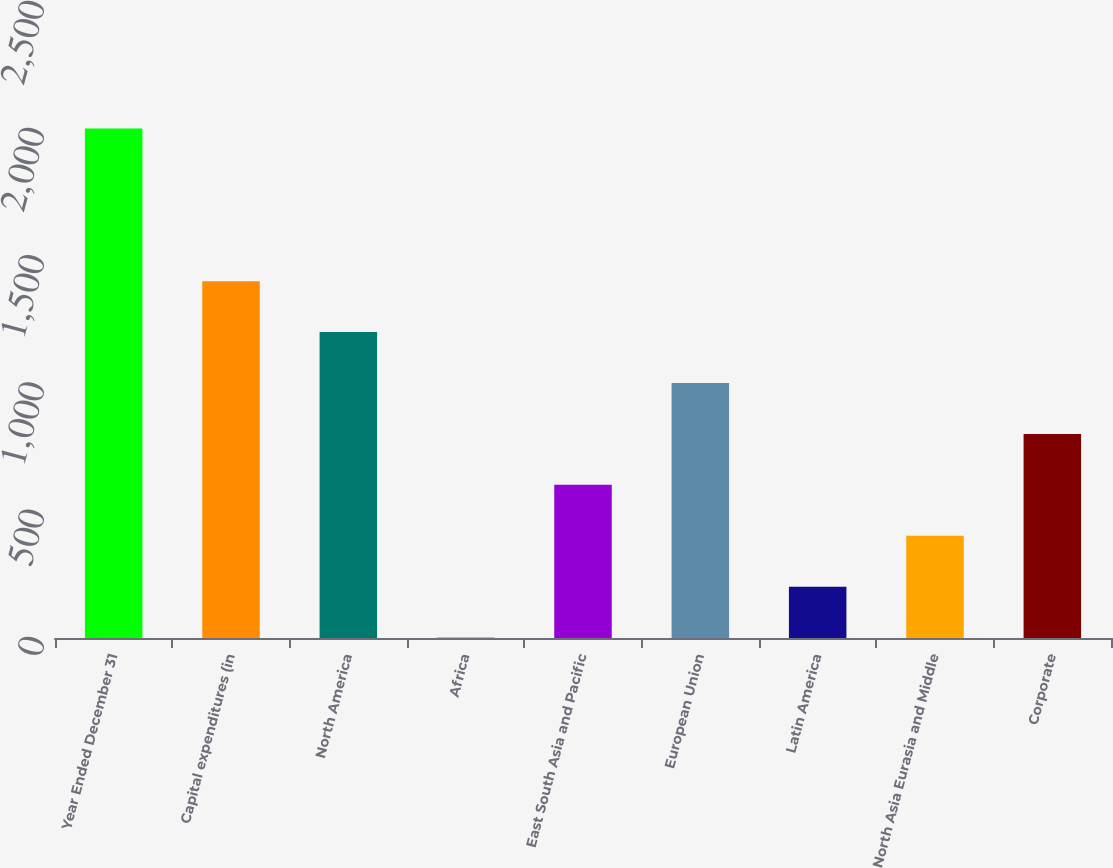Convert chart to OTSL. <chart><loc_0><loc_0><loc_500><loc_500><bar_chart><fcel>Year Ended December 31<fcel>Capital expenditures (in<fcel>North America<fcel>Africa<fcel>East South Asia and Pacific<fcel>European Union<fcel>Latin America<fcel>North Asia Eurasia and Middle<fcel>Corporate<nl><fcel>2003<fcel>1402.58<fcel>1202.44<fcel>1.6<fcel>602.02<fcel>1002.3<fcel>201.74<fcel>401.88<fcel>802.16<nl></chart> 